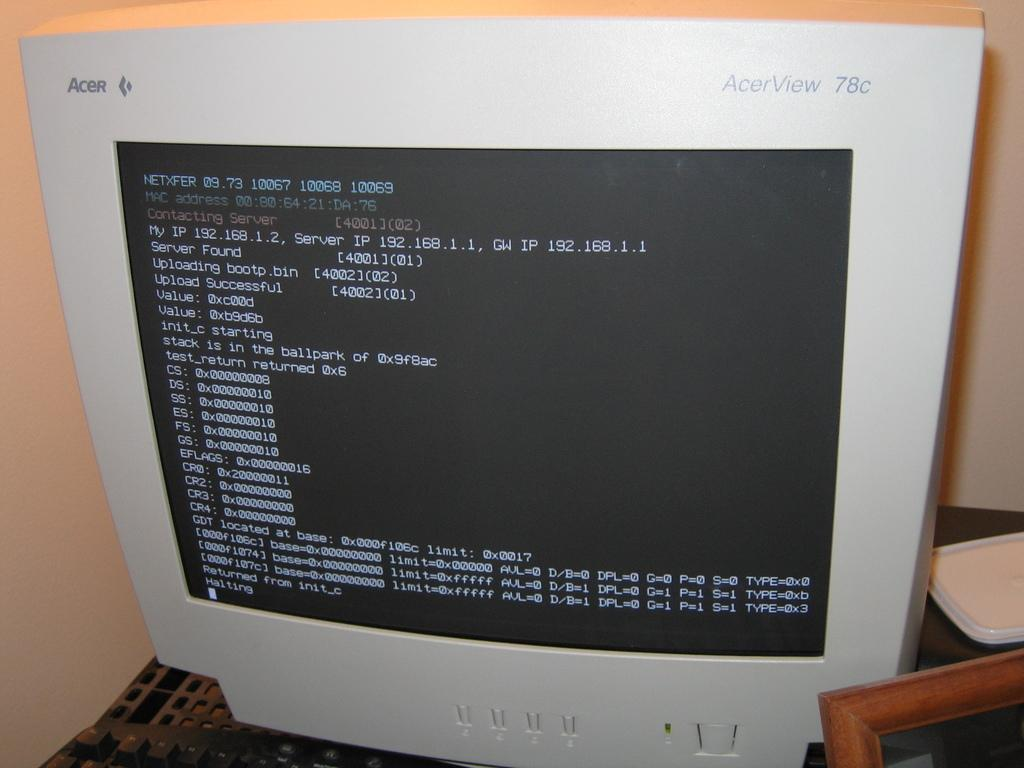<image>
Render a clear and concise summary of the photo. Old AcerView computer monitor that has a black screen. 